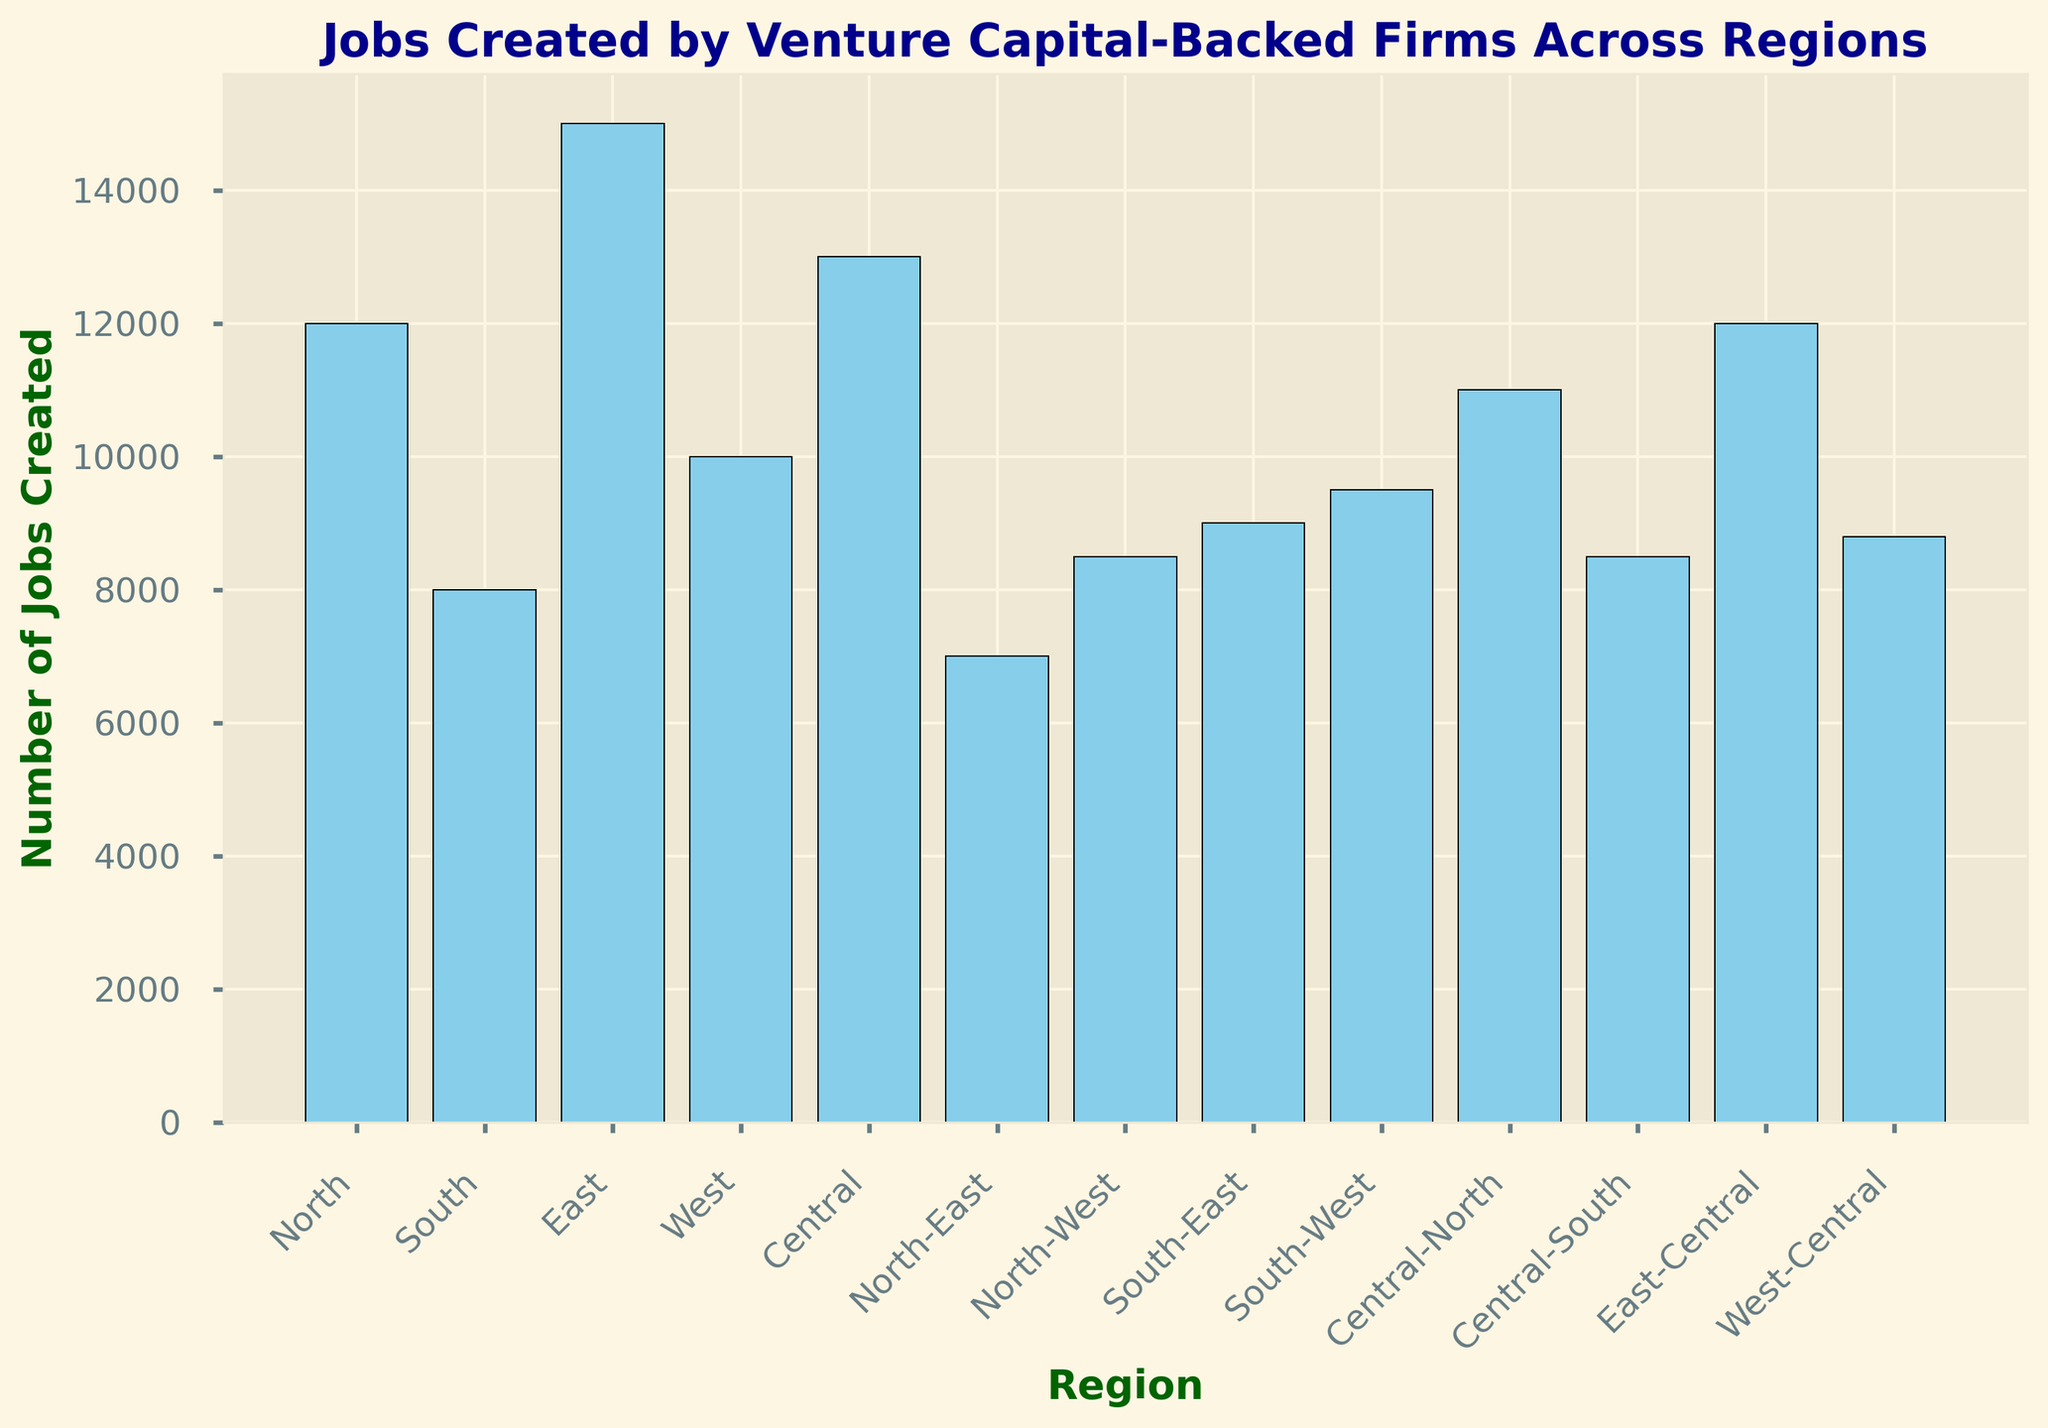What is the total number of jobs created in the North and East regions combined? To find the total number of jobs created in both the North and East regions, sum the job counts for these regions. North has 12,000 jobs, and East has 15,000 jobs. Therefore, the total is 12,000 + 15,000 = 27,000.
Answer: 27,000 Which region created the fewest number of jobs? To determine which region created the fewest jobs, examine the heights of the bars in the chart and find the shortest one. The North-East region, with 7,000 jobs, created the fewest jobs.
Answer: North-East How many more jobs were created in the Central region compared to the South region? Subtract the number of jobs created in the South region from the number of jobs created in the Central region. Central has 13,000 jobs, and South has 8,000 jobs. Thus, 13,000 - 8,000 = 5,000.
Answer: 5,000 Is the number of jobs created in Central-South greater than that in North-West? Compare the heights of the bars for the Central-South and North-West regions. Central-South has 8,500 jobs, and North-West also has 8,500 jobs. Since they are equal, the answer is no.
Answer: No What is the average number of jobs created across all regions? To find the average number of jobs created, sum the number of jobs in all regions and divide by the number of regions. Total is 12,000 (North) + 8,000 (South) + 15,000 (East) + 10,000 (West) + 13,000 (Central) + 7,000 (North-East) + 8,500 (North-West) + 9,000 (South-East) + 9,500 (South-West) + 11,000 (Central-North) + 8,500 (Central-South) + 12,000 (East-Central) + 8,800 (West-Central) = 133,300. Divide by the number of regions (13), so 133,300 / 13 ≠ 10,254 approximately.
Answer: 10,254 Which region created the highest number of jobs? To find the region that created the highest number of jobs, look for the tallest bar in the chart. The East region, with 15,000 jobs, created the highest number of jobs.
Answer: East Are there more jobs created in the combined North-West and South-West regions than in the East region? Sum the jobs in the North-West (8,500) and South-West (9,500) regions and compare with East (15,000). Combined is 8,500 + 9,500 = 18,000, which is greater than 15,000. Thus, the combined regions created more jobs.
Answer: Yes Which regions have created an equal number of jobs? Look for bars of equal height to identify regions with the same number of jobs. The Central-South and North-West regions both created 8,500 jobs.
Answer: Central-South and North-West 